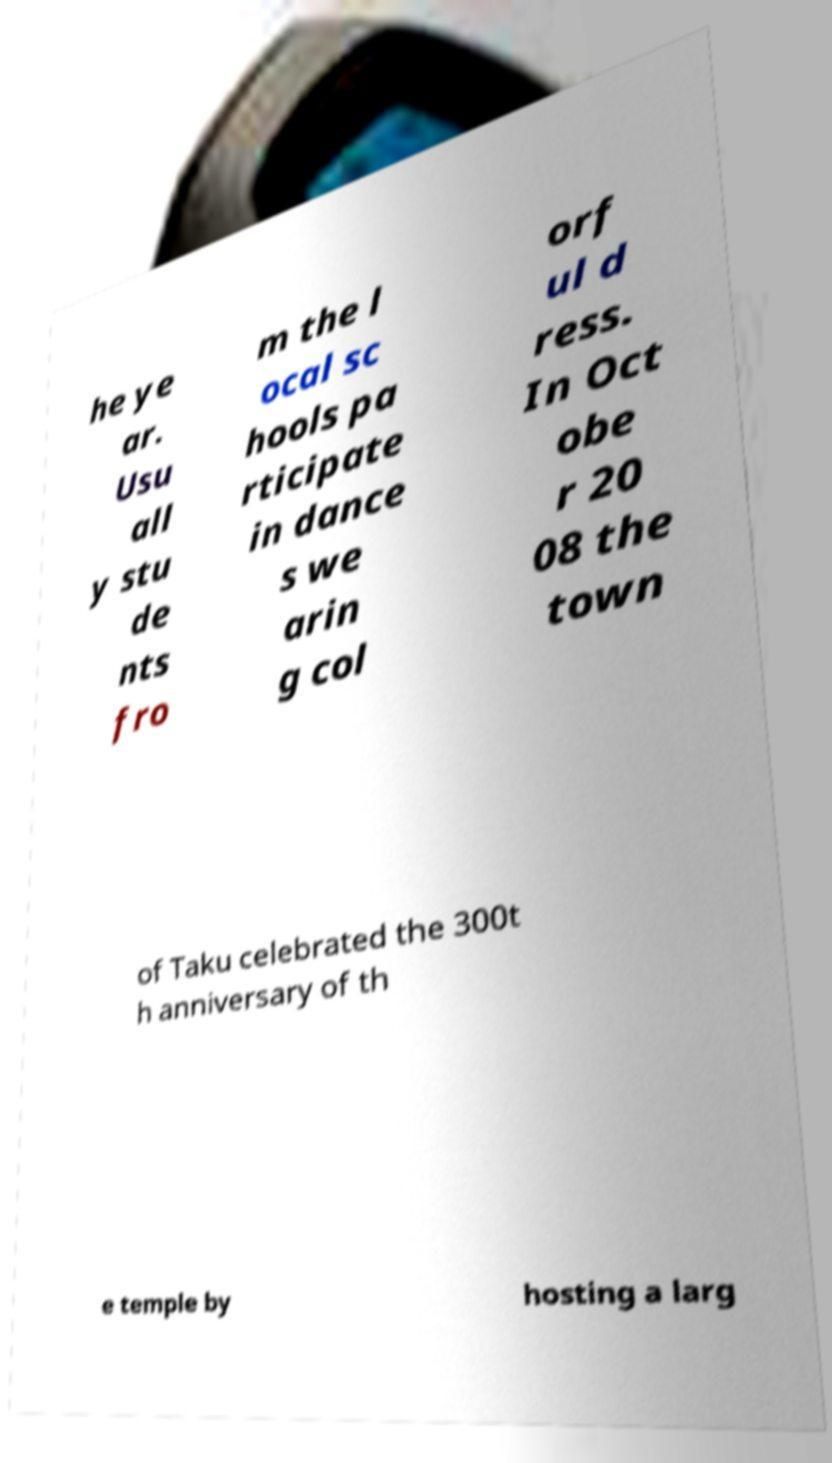Please identify and transcribe the text found in this image. he ye ar. Usu all y stu de nts fro m the l ocal sc hools pa rticipate in dance s we arin g col orf ul d ress. In Oct obe r 20 08 the town of Taku celebrated the 300t h anniversary of th e temple by hosting a larg 